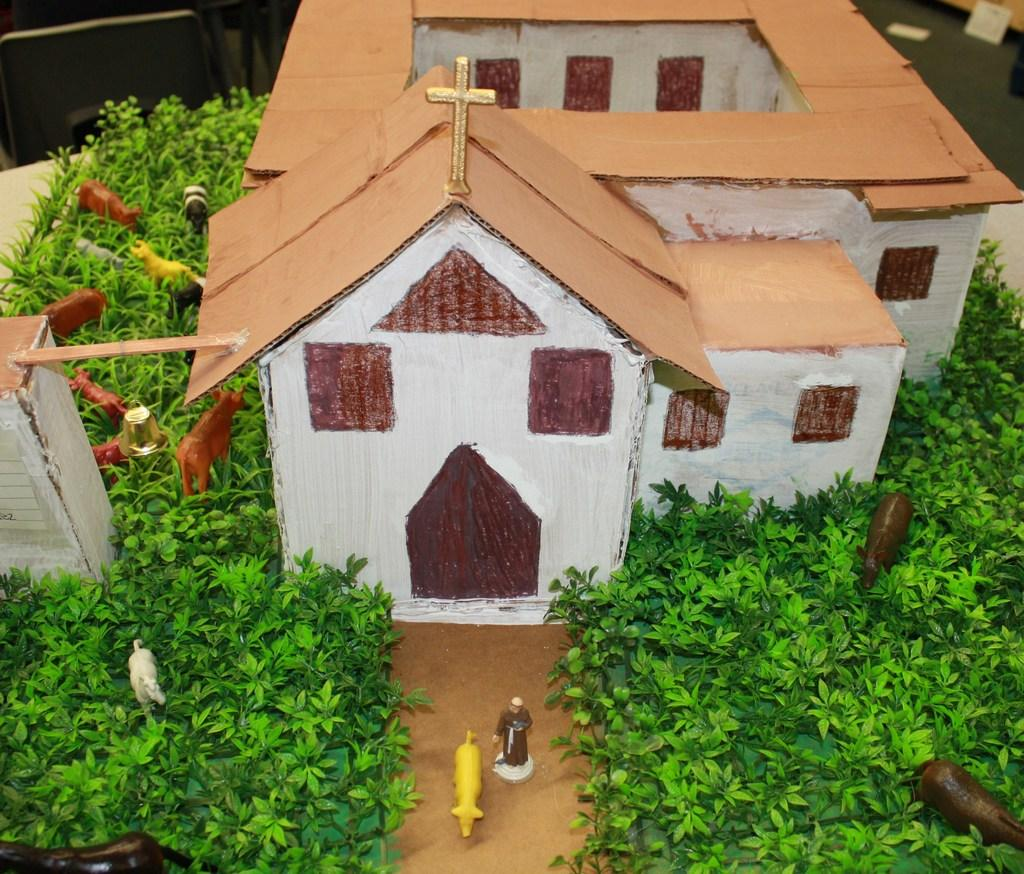What is the main structure in the center of the image? There is a house made with cardboard in the center of the image. What can be seen in the background of the image? There are artificial animals and artificial plants in the background of the image. Where is the dock located in the image? There is no dock present in the image. Can you describe the kitten playing with the door in the image? There is no kitten or door present in the image. 